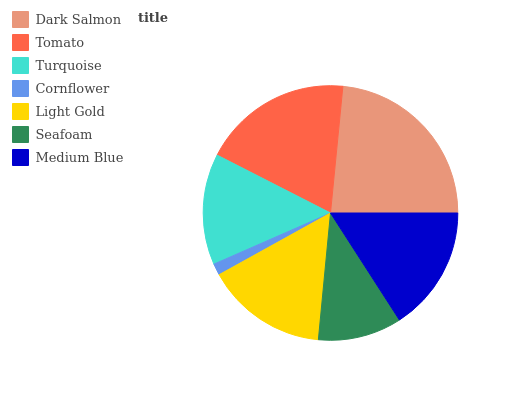Is Cornflower the minimum?
Answer yes or no. Yes. Is Dark Salmon the maximum?
Answer yes or no. Yes. Is Tomato the minimum?
Answer yes or no. No. Is Tomato the maximum?
Answer yes or no. No. Is Dark Salmon greater than Tomato?
Answer yes or no. Yes. Is Tomato less than Dark Salmon?
Answer yes or no. Yes. Is Tomato greater than Dark Salmon?
Answer yes or no. No. Is Dark Salmon less than Tomato?
Answer yes or no. No. Is Light Gold the high median?
Answer yes or no. Yes. Is Light Gold the low median?
Answer yes or no. Yes. Is Turquoise the high median?
Answer yes or no. No. Is Medium Blue the low median?
Answer yes or no. No. 